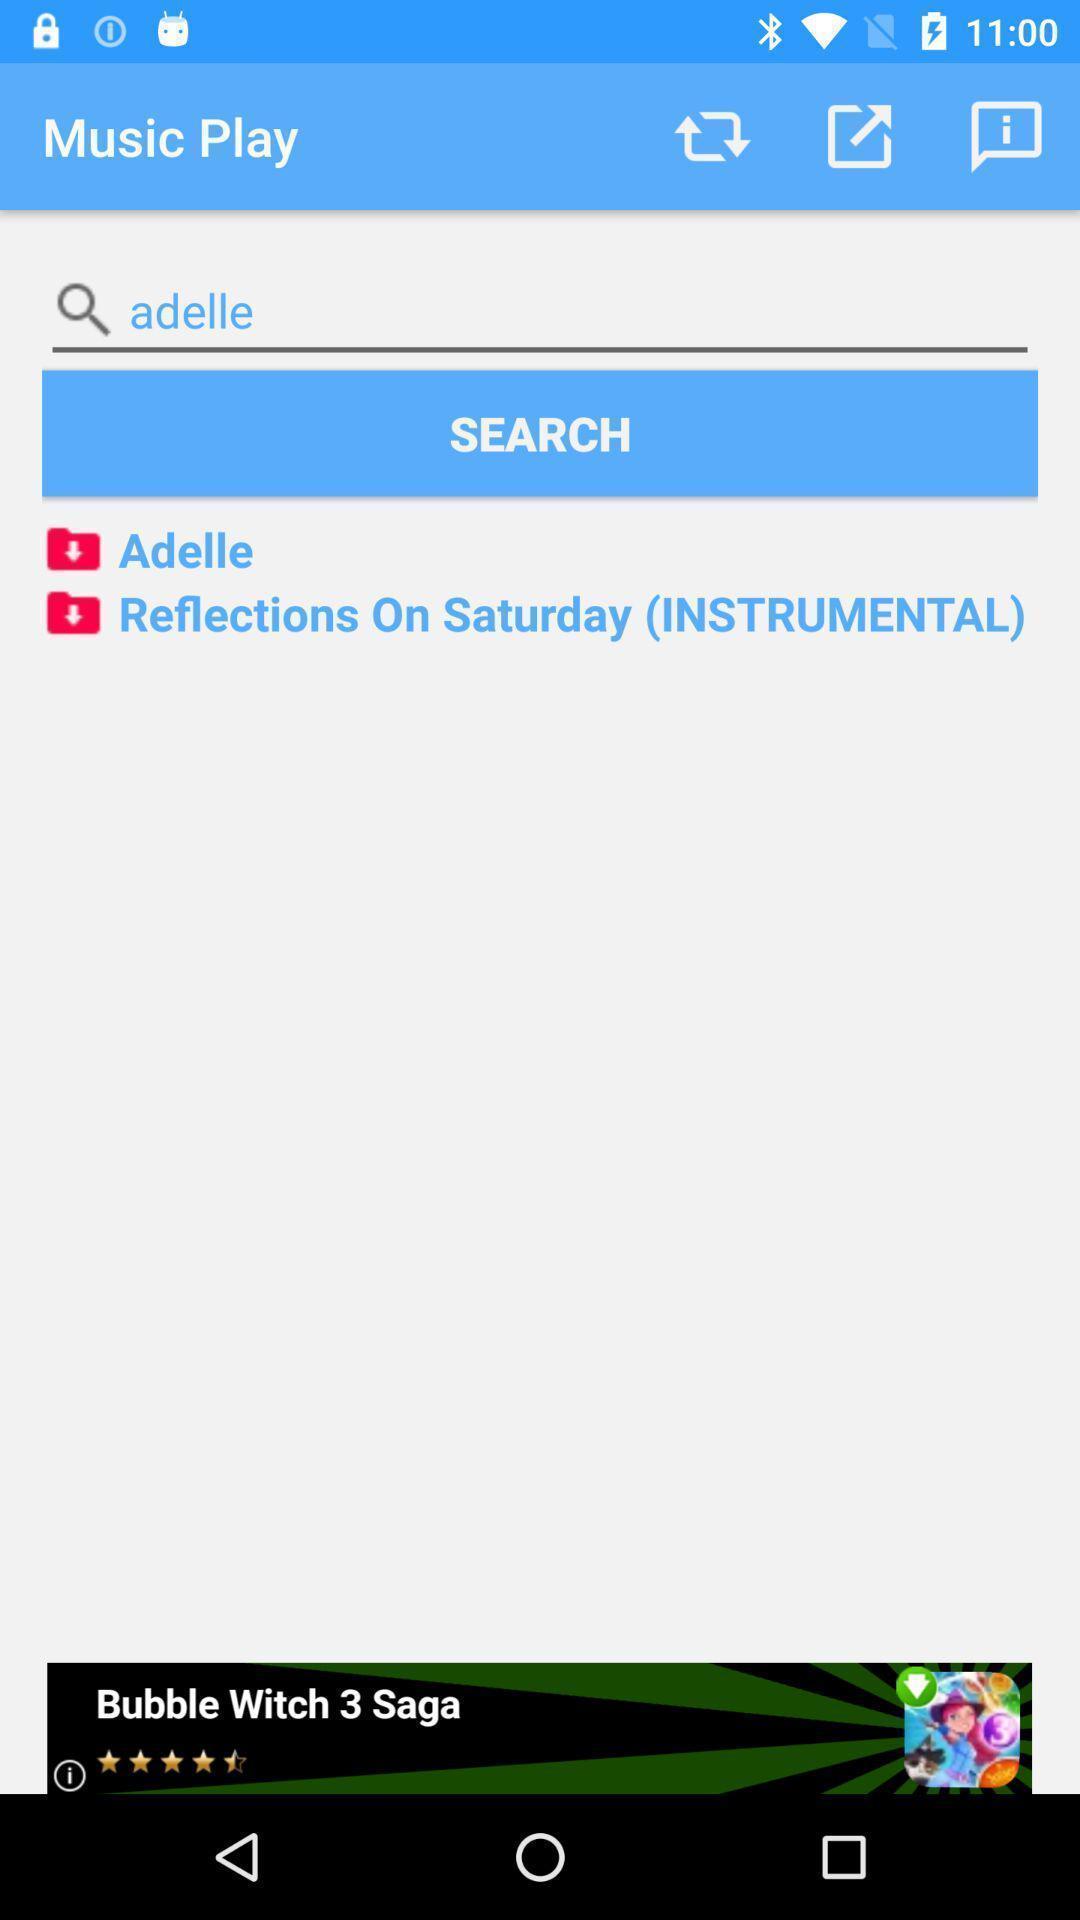Tell me what you see in this picture. Search page to find artists and songs. 